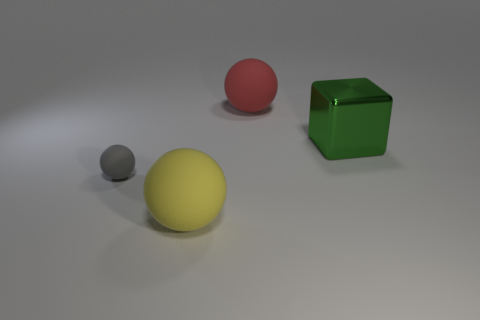Add 3 large shiny things. How many objects exist? 7 Subtract all cubes. How many objects are left? 3 Add 2 tiny cyan metallic balls. How many tiny cyan metallic balls exist? 2 Subtract 0 brown balls. How many objects are left? 4 Subtract all tiny red shiny spheres. Subtract all big yellow spheres. How many objects are left? 3 Add 1 large yellow matte objects. How many large yellow matte objects are left? 2 